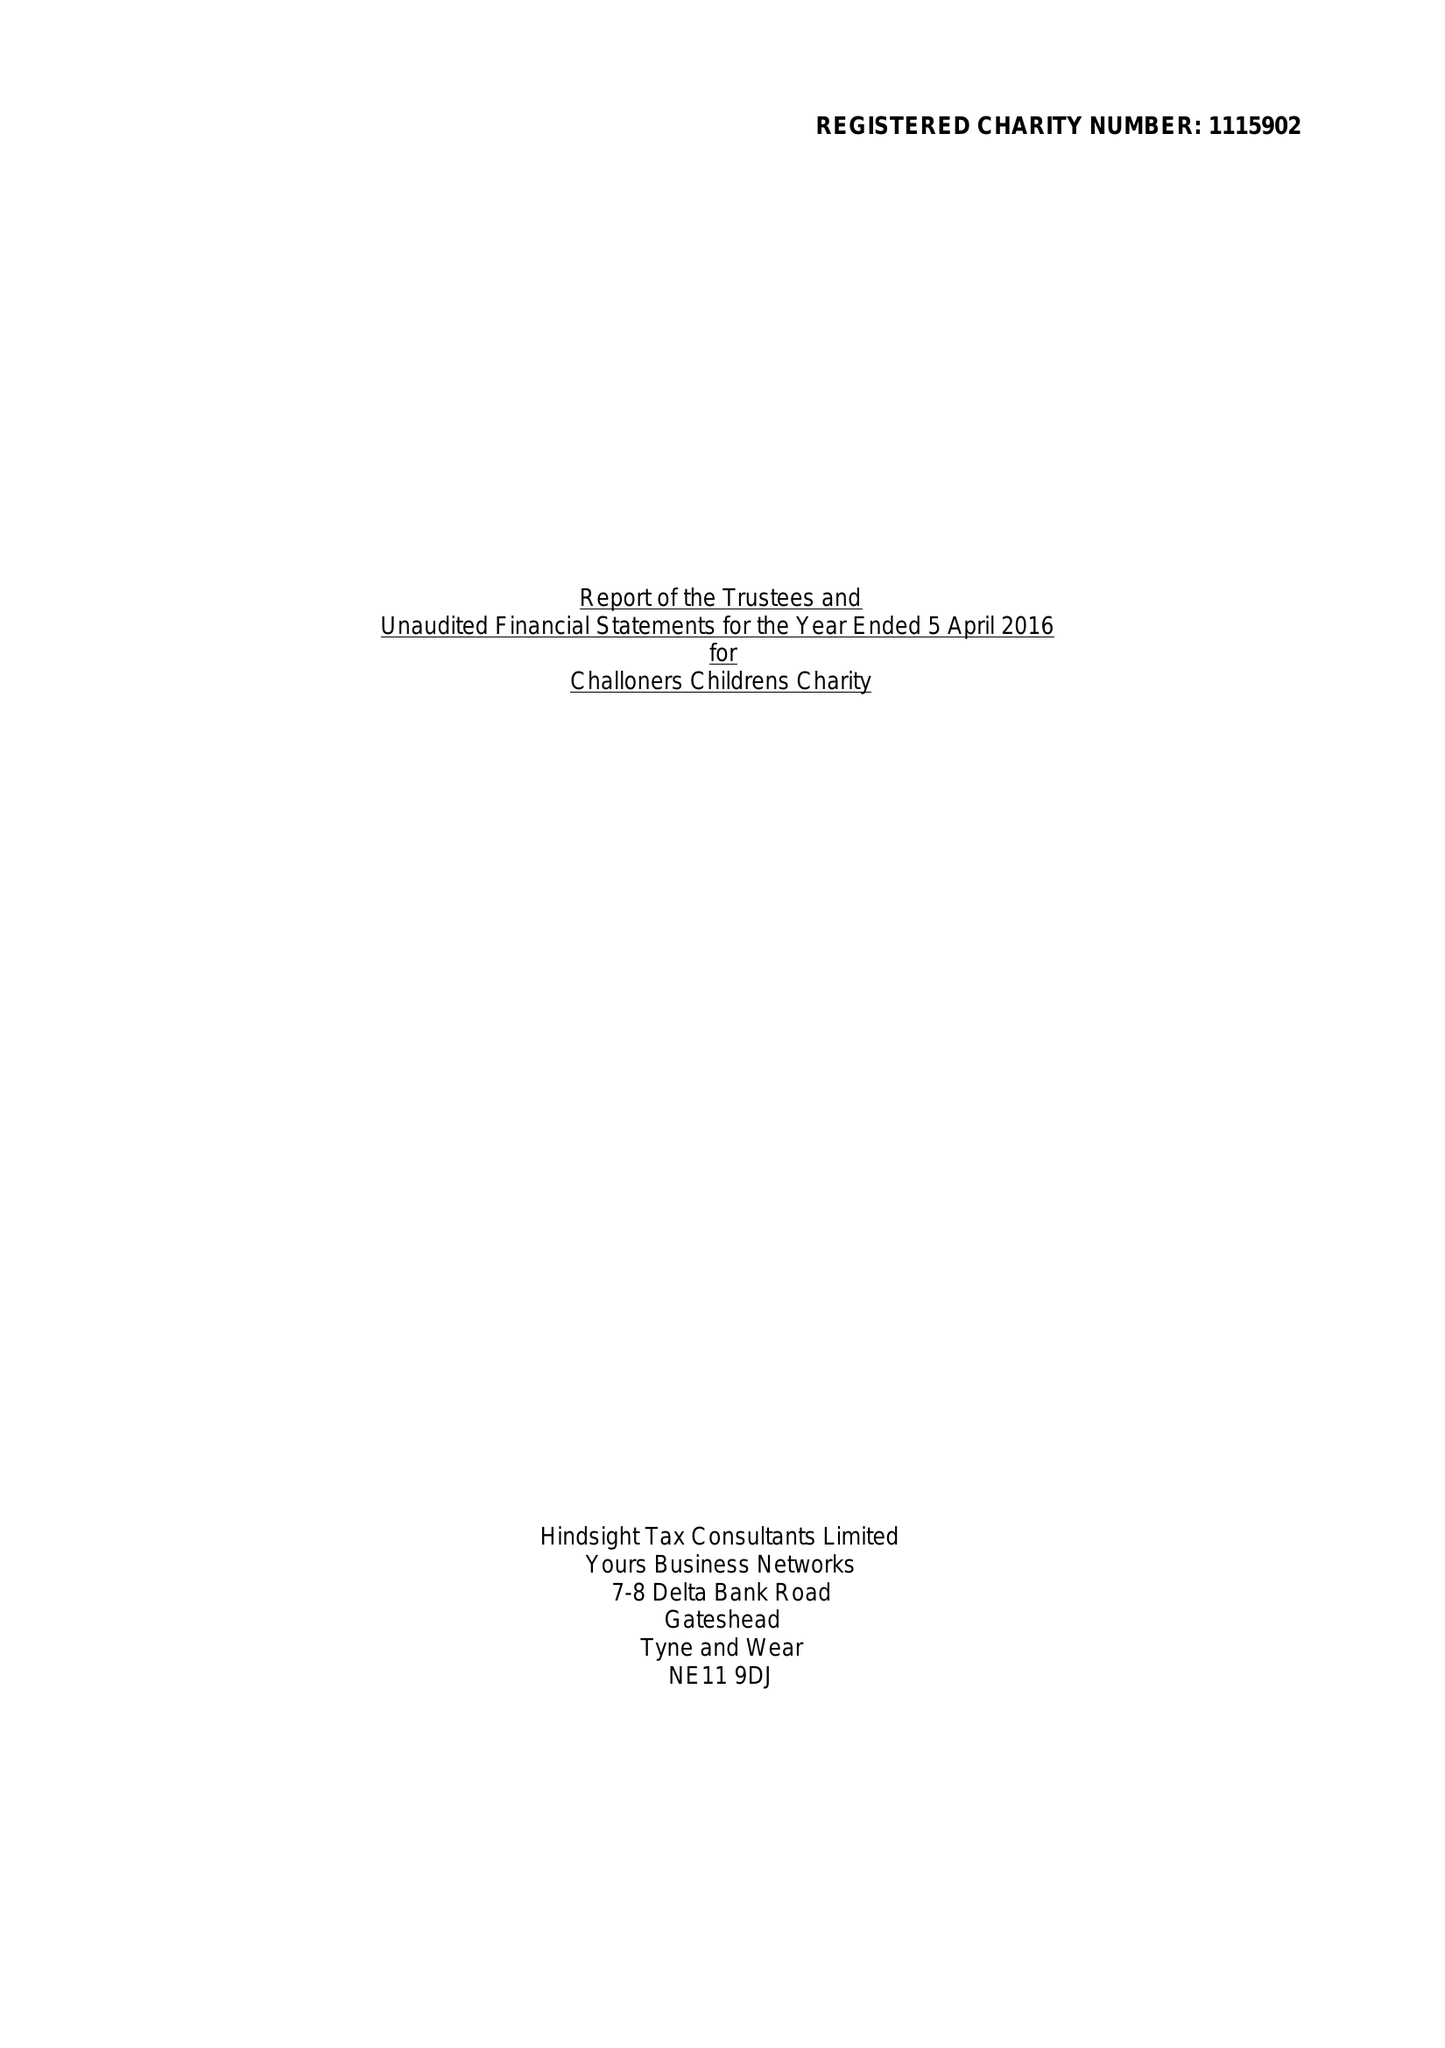What is the value for the income_annually_in_british_pounds?
Answer the question using a single word or phrase. 100850.00 